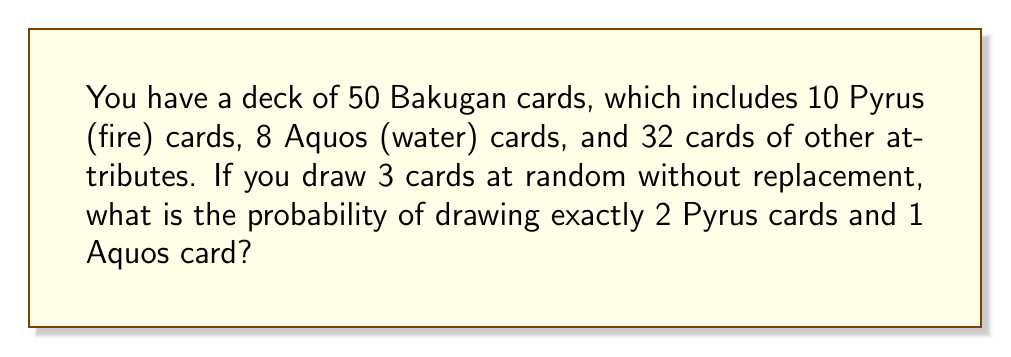What is the answer to this math problem? Let's approach this problem using set theory and combination principles:

1) First, we need to calculate the number of ways to select 2 Pyrus cards from 10 Pyrus cards:
   $$\binom{10}{2} = \frac{10!}{2!(10-2)!} = \frac{10 \cdot 9}{2 \cdot 1} = 45$$

2) Then, we need to calculate the number of ways to select 1 Aquos card from 8 Aquos cards:
   $$\binom{8}{1} = 8$$

3) The total number of favorable outcomes is the product of these two values:
   $$45 \cdot 8 = 360$$

4) Now, we need to calculate the total number of ways to draw 3 cards from 50 cards:
   $$\binom{50}{3} = \frac{50!}{3!(50-3)!} = \frac{50 \cdot 49 \cdot 48}{3 \cdot 2 \cdot 1} = 19,600$$

5) The probability is the number of favorable outcomes divided by the total number of possible outcomes:

   $$P(\text{2 Pyrus and 1 Aquos}) = \frac{360}{19,600} = \frac{9}{490} \approx 0.01837$$

Therefore, the probability of drawing exactly 2 Pyrus cards and 1 Aquos card when drawing 3 cards at random from this deck is $\frac{9}{490}$ or approximately 0.01837 or 1.837%.
Answer: $\frac{9}{490}$ or approximately 0.01837 (1.837%) 